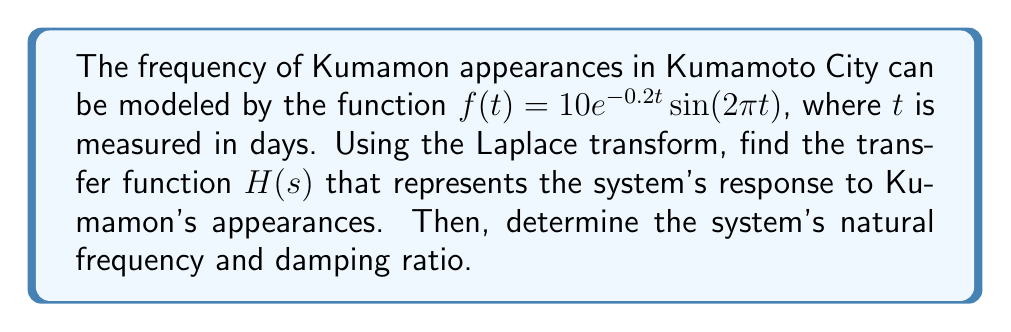Can you answer this question? Let's approach this step-by-step:

1) The Laplace transform of $f(t) = 10e^{-0.2t}\sin(2\pi t)$ is needed. We can use the standard Laplace transform pair:

   $$\mathcal{L}\{e^{-at}\sin(bt)\} = \frac{b}{(s+a)^2 + b^2}$$

2) In our case, $a = 0.2$ and $b = 2\pi$. Also, we have a factor of 10. So:

   $$F(s) = \mathcal{L}\{f(t)\} = \frac{20\pi}{(s+0.2)^2 + (2\pi)^2}$$

3) The transfer function $H(s)$ is the ratio of the output to the input in the s-domain. Here, $F(s)$ represents the output, and we can assume a unit impulse input (which has a Laplace transform of 1). Therefore:

   $$H(s) = \frac{F(s)}{1} = F(s) = \frac{20\pi}{(s+0.2)^2 + (2\pi)^2}$$

4) To find the natural frequency and damping ratio, we need to put $H(s)$ in the standard form:

   $$H(s) = \frac{\omega_n^2}{s^2 + 2\zeta\omega_n s + \omega_n^2}$$

5) Expanding our $H(s)$:

   $$H(s) = \frac{20\pi}{s^2 + 0.4s + 0.04 + (2\pi)^2}$$

6) Comparing this to the standard form, we can see that:

   $$\omega_n^2 = 0.04 + (2\pi)^2 \approx 39.48$$
   $$2\zeta\omega_n = 0.4$$

7) From these, we can calculate:

   $$\omega_n = \sqrt{39.48} \approx 6.28 \text{ rad/day}$$
   $$\zeta = \frac{0.4}{2\omega_n} = \frac{0.4}{2(6.28)} \approx 0.0318$$
Answer: The transfer function is $H(s) = \frac{20\pi}{(s+0.2)^2 + (2\pi)^2}$. The natural frequency is $\omega_n \approx 6.28 \text{ rad/day}$, and the damping ratio is $\zeta \approx 0.0318$. 